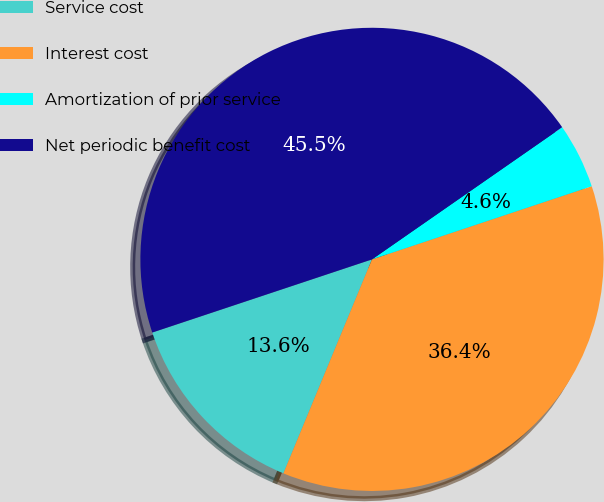Convert chart. <chart><loc_0><loc_0><loc_500><loc_500><pie_chart><fcel>Service cost<fcel>Interest cost<fcel>Amortization of prior service<fcel>Net periodic benefit cost<nl><fcel>13.64%<fcel>36.36%<fcel>4.55%<fcel>45.45%<nl></chart> 